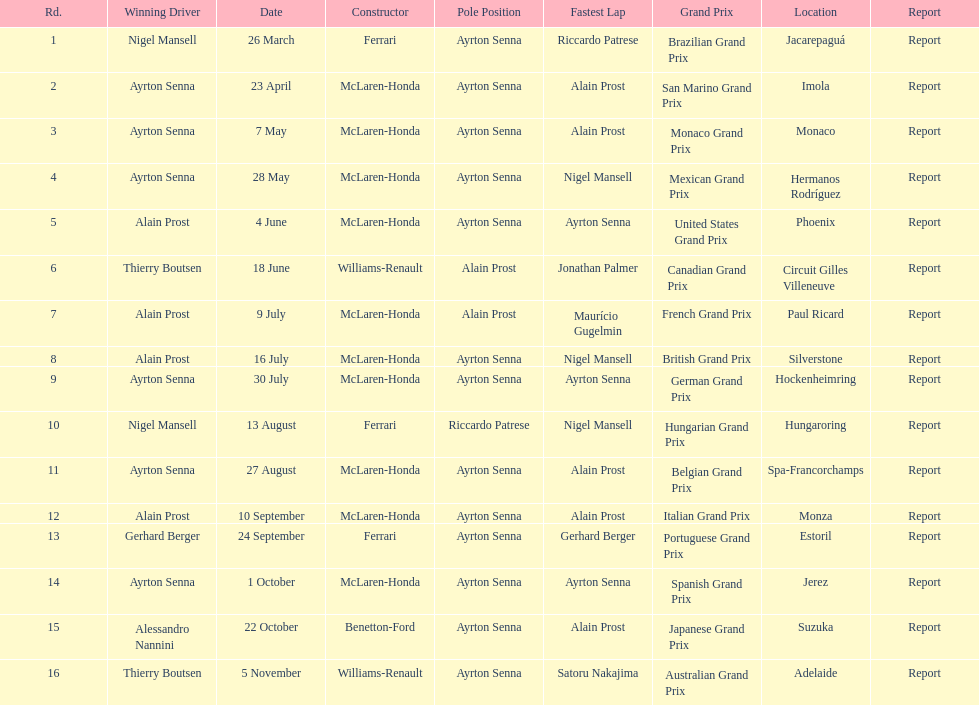How many times was ayrton senna in pole position? 13. 